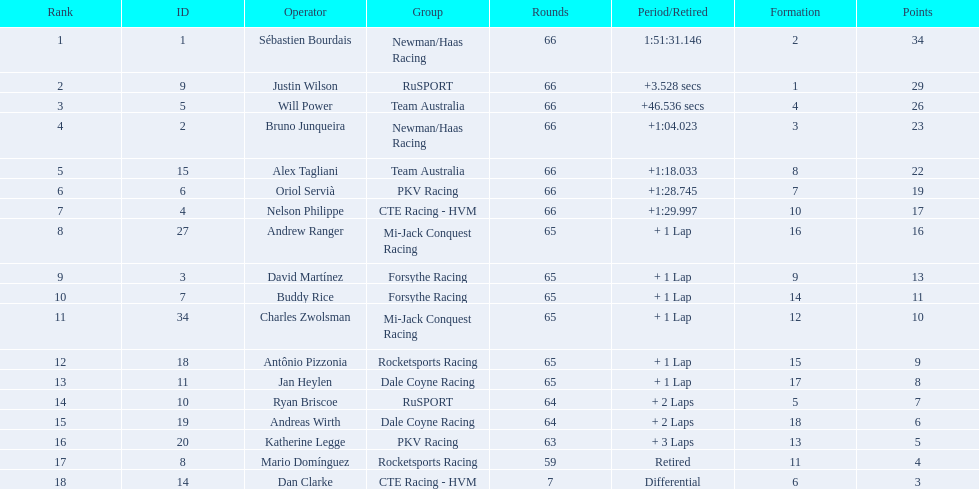Which drivers scored at least 10 points? Sébastien Bourdais, Justin Wilson, Will Power, Bruno Junqueira, Alex Tagliani, Oriol Servià, Nelson Philippe, Andrew Ranger, David Martínez, Buddy Rice, Charles Zwolsman. Of those drivers, which ones scored at least 20 points? Sébastien Bourdais, Justin Wilson, Will Power, Bruno Junqueira, Alex Tagliani. Of those 5, which driver scored the most points? Sébastien Bourdais. 